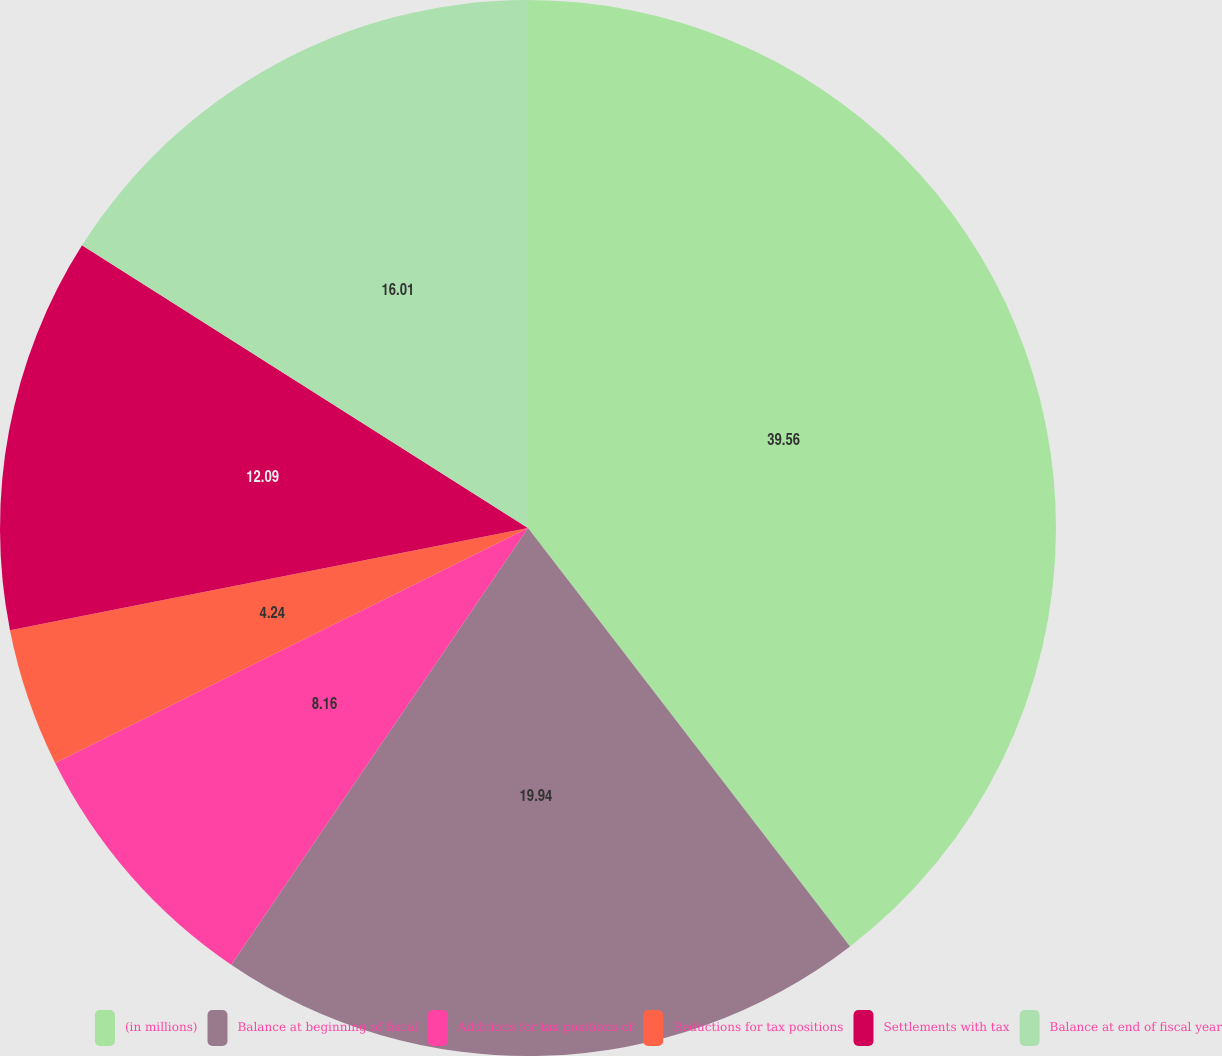Convert chart. <chart><loc_0><loc_0><loc_500><loc_500><pie_chart><fcel>(in millions)<fcel>Balance at beginning of fiscal<fcel>Additions for tax positions of<fcel>Reductions for tax positions<fcel>Settlements with tax<fcel>Balance at end of fiscal year<nl><fcel>39.56%<fcel>19.94%<fcel>8.16%<fcel>4.24%<fcel>12.09%<fcel>16.01%<nl></chart> 